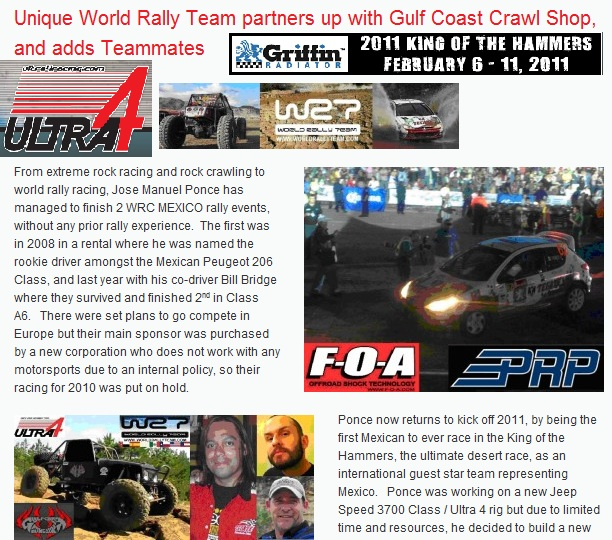What are some notable events mentioned in the image? The image prominently features notable events such as the WRC Mexico and the King of the Hammers (held from February 6-11, 2011). WRC Mexico is an event where Jose Manuel Ponce participated twice, achieving significant success. The King of the Hammers is highlighted as one of the ultimate desert races, emphasizing the challenging nature of this motorsport event. Can you provide more details about the King of the Hammers event? The King of the Hammers is considered one of the most challenging off-roading events, combining desert racing speeds with rock crawling. It's an ultimate test of endurance, navigation, and vehicle durability, held annually in Johnson Valley, California. Competitors undergo rigorous conditions, including navigating through harsh desert terrain and complex rock formations. Being a part of this event denotes a significant achievement in the off-road racing community. 